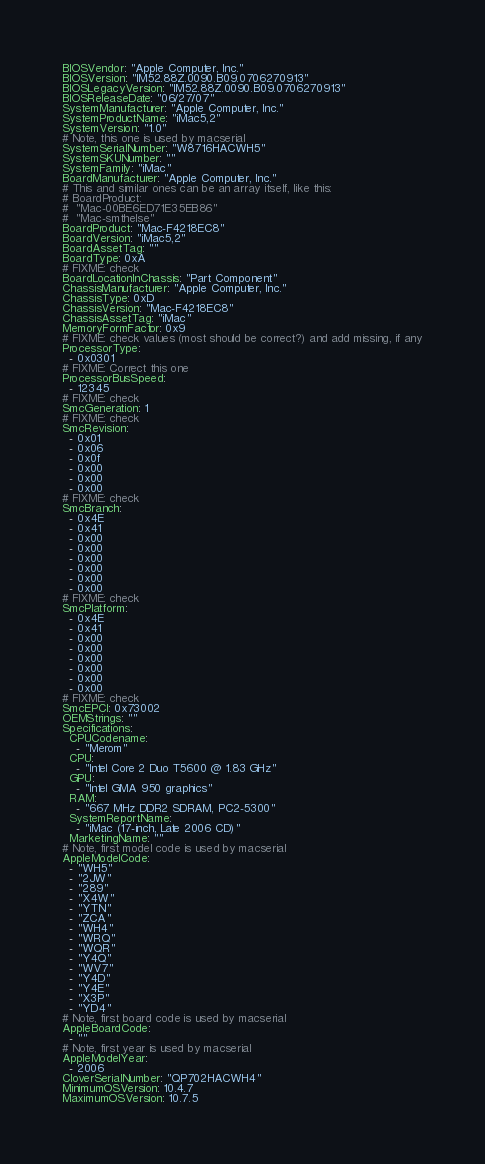<code> <loc_0><loc_0><loc_500><loc_500><_YAML_>BIOSVendor: "Apple Computer, Inc."
BIOSVersion: "IM52.88Z.0090.B09.0706270913"
BIOSLegacyVersion: "IM52.88Z.0090.B09.0706270913"
BIOSReleaseDate: "06/27/07"
SystemManufacturer: "Apple Computer, Inc."
SystemProductName: "iMac5,2"
SystemVersion: "1.0"
# Note, this one is used by macserial
SystemSerialNumber: "W8716HACWH5"
SystemSKUNumber: ""
SystemFamily: "iMac"
BoardManufacturer: "Apple Computer, Inc."
# This and similar ones can be an array itself, like this:
# BoardProduct:
#  "Mac-00BE6ED71E35EB86"
#  "Mac-smthelse"
BoardProduct: "Mac-F4218EC8"
BoardVersion: "iMac5,2"
BoardAssetTag: ""
BoardType: 0xA
# FIXME: check
BoardLocationInChassis: "Part Component"
ChassisManufacturer: "Apple Computer, Inc."
ChassisType: 0xD
ChassisVersion: "Mac-F4218EC8"
ChassisAssetTag: "iMac"
MemoryFormFactor: 0x9
# FIXME: check values (most should be correct?) and add missing, if any
ProcessorType:
  - 0x0301
# FIXME: Correct this one
ProcessorBusSpeed:
  - 12345
# FIXME: check
SmcGeneration: 1
# FIXME: check
SmcRevision:
  - 0x01
  - 0x06
  - 0x0f
  - 0x00
  - 0x00
  - 0x00
# FIXME: check
SmcBranch:
  - 0x4E
  - 0x41
  - 0x00
  - 0x00
  - 0x00
  - 0x00
  - 0x00
  - 0x00
# FIXME: check
SmcPlatform:
  - 0x4E
  - 0x41
  - 0x00
  - 0x00
  - 0x00
  - 0x00
  - 0x00
  - 0x00
# FIXME: check
SmcEPCI: 0x73002
OEMStrings: ""
Specifications:
  CPUCodename:
    - "Merom"
  CPU:
    - "Intel Core 2 Duo T5600 @ 1.83 GHz"
  GPU:
    - "Intel GMA 950 graphics"
  RAM:
    - "667 MHz DDR2 SDRAM, PC2-5300"
  SystemReportName:
    - "iMac (17-inch, Late 2006 CD)"
  MarketingName: ""
# Note, first model code is used by macserial
AppleModelCode:
  - "WH5"
  - "2JW"
  - "289"
  - "X4W"
  - "YTN"
  - "ZCA"
  - "WH4"
  - "WRQ"
  - "WQR"
  - "Y4Q"
  - "WV7"
  - "Y4D"
  - "Y4E"
  - "X3P"
  - "YD4"
# Note, first board code is used by macserial
AppleBoardCode:
  - ""
# Note, first year is used by macserial
AppleModelYear:
  - 2006
CloverSerialNumber: "QP702HACWH4"
MinimumOSVersion: 10.4.7
MaximumOSVersion: 10.7.5
</code> 